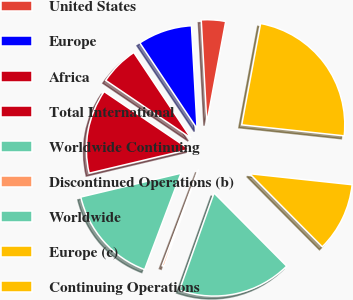Convert chart to OTSL. <chart><loc_0><loc_0><loc_500><loc_500><pie_chart><fcel>United States<fcel>Europe<fcel>Africa<fcel>Total International<fcel>Worldwide Continuing<fcel>Discontinued Operations (b)<fcel>Worldwide<fcel>Europe (c)<fcel>Continuing Operations<nl><fcel>3.8%<fcel>8.5%<fcel>6.15%<fcel>13.19%<fcel>15.54%<fcel>0.3%<fcel>17.89%<fcel>10.85%<fcel>23.77%<nl></chart> 